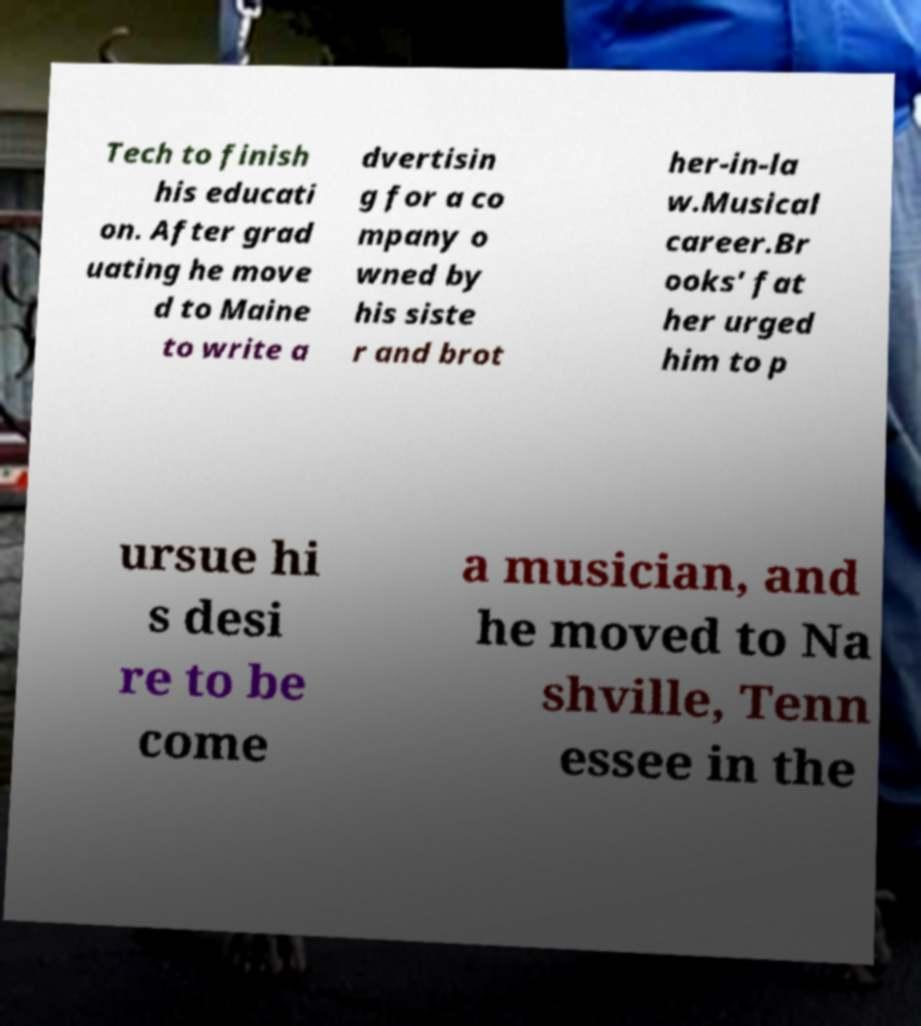What messages or text are displayed in this image? I need them in a readable, typed format. Tech to finish his educati on. After grad uating he move d to Maine to write a dvertisin g for a co mpany o wned by his siste r and brot her-in-la w.Musical career.Br ooks' fat her urged him to p ursue hi s desi re to be come a musician, and he moved to Na shville, Tenn essee in the 